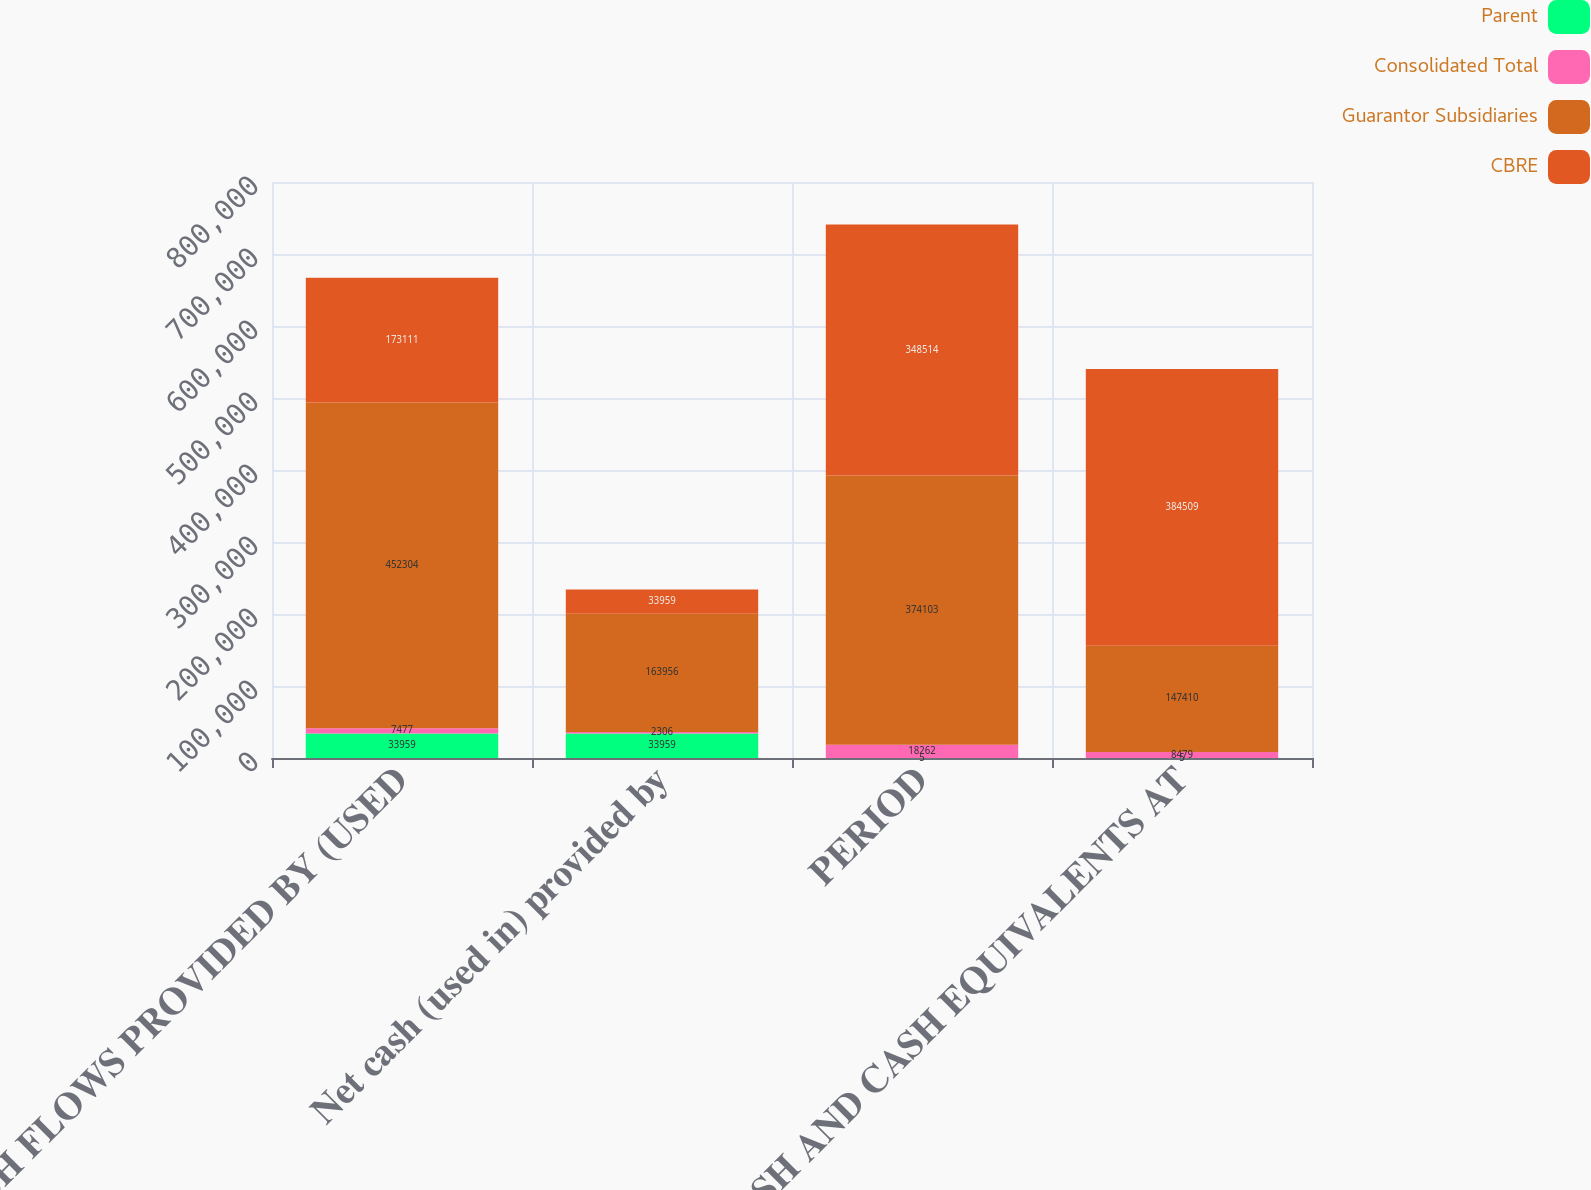Convert chart to OTSL. <chart><loc_0><loc_0><loc_500><loc_500><stacked_bar_chart><ecel><fcel>CASH FLOWS PROVIDED BY (USED<fcel>Net cash (used in) provided by<fcel>PERIOD<fcel>CASH AND CASH EQUIVALENTS AT<nl><fcel>Parent<fcel>33959<fcel>33959<fcel>5<fcel>5<nl><fcel>Consolidated Total<fcel>7477<fcel>2306<fcel>18262<fcel>8479<nl><fcel>Guarantor Subsidiaries<fcel>452304<fcel>163956<fcel>374103<fcel>147410<nl><fcel>CBRE<fcel>173111<fcel>33959<fcel>348514<fcel>384509<nl></chart> 